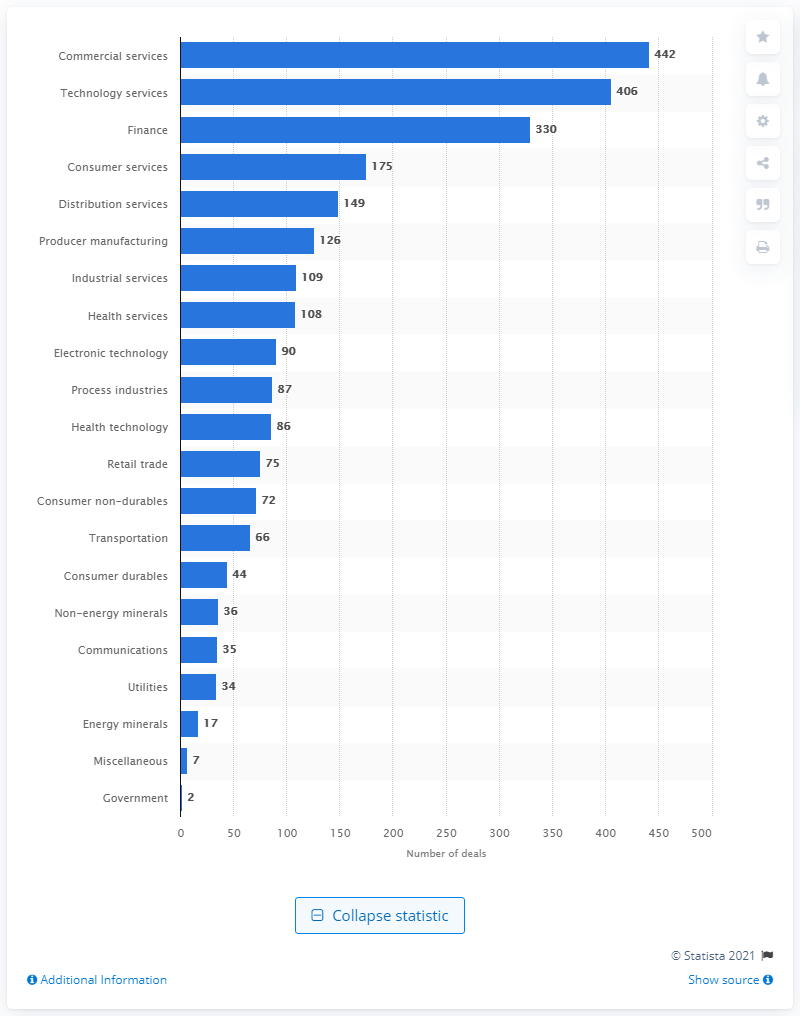Give some essential details in this illustration. There were 442 mergers and acquisitions (M&A) deals between November 2019 and April 2020. 